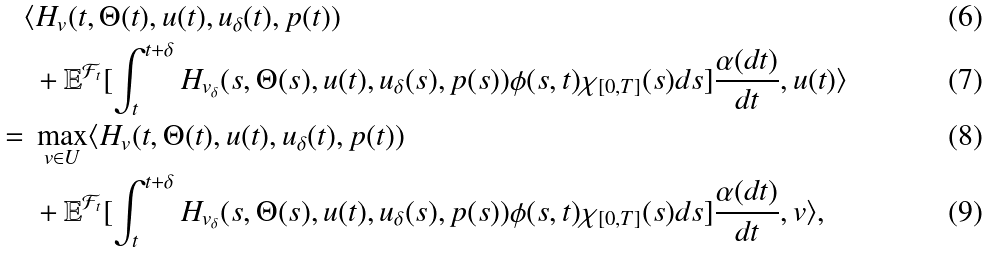<formula> <loc_0><loc_0><loc_500><loc_500>& \langle H _ { v } ( t , \Theta ( t ) , u ( t ) , u _ { \delta } ( t ) , p ( t ) ) \\ & \ + \mathbb { E } ^ { \mathcal { F } _ { t } } [ \int ^ { t + \delta } _ { t } H _ { v _ { \delta } } ( s , \Theta ( s ) , u ( t ) , u _ { \delta } ( s ) , p ( s ) ) \phi ( s , t ) \chi _ { [ 0 , T ] } ( s ) d s ] \frac { \alpha ( d t ) } { d t } , u ( t ) \rangle \\ = & \ \max _ { v \in U } \langle H _ { v } ( t , \Theta ( t ) , u ( t ) , u _ { \delta } ( t ) , p ( t ) ) \\ & \ + \mathbb { E } ^ { \mathcal { F } _ { t } } [ \int ^ { t + \delta } _ { t } H _ { v _ { \delta } } ( s , \Theta ( s ) , u ( t ) , u _ { \delta } ( s ) , p ( s ) ) \phi ( s , t ) \chi _ { [ 0 , T ] } ( s ) d s ] \frac { \alpha ( d t ) } { d t } , v \rangle ,</formula> 